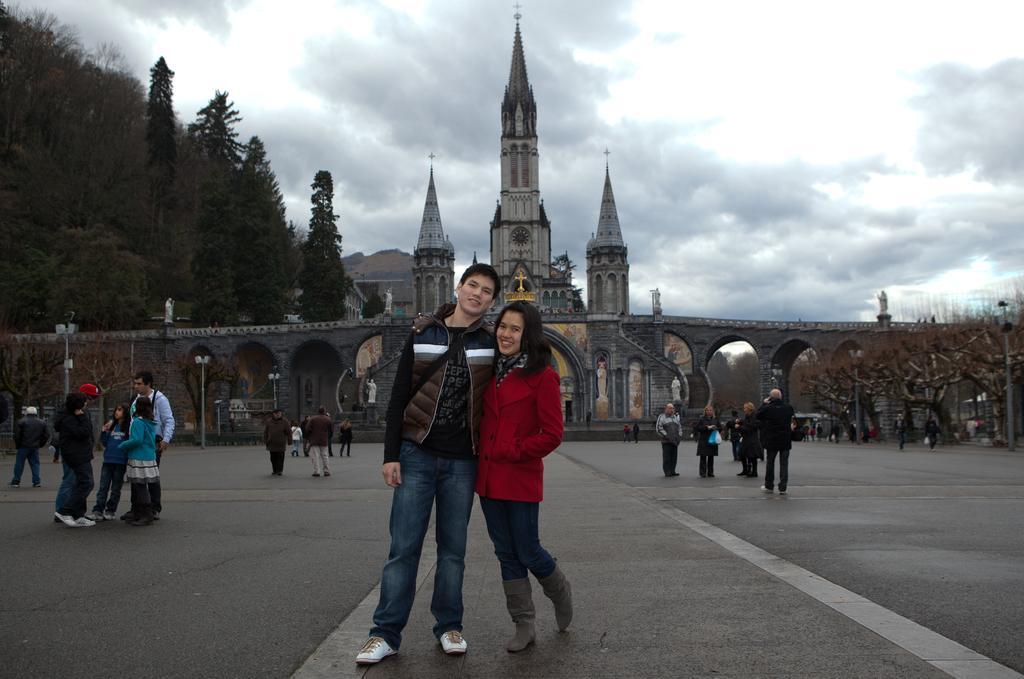Please provide a concise description of this image. This picture describes about group of people, few are standing and few are walking, in the background we can see few poles, lights, trees and a building, and also we can see clouds. 